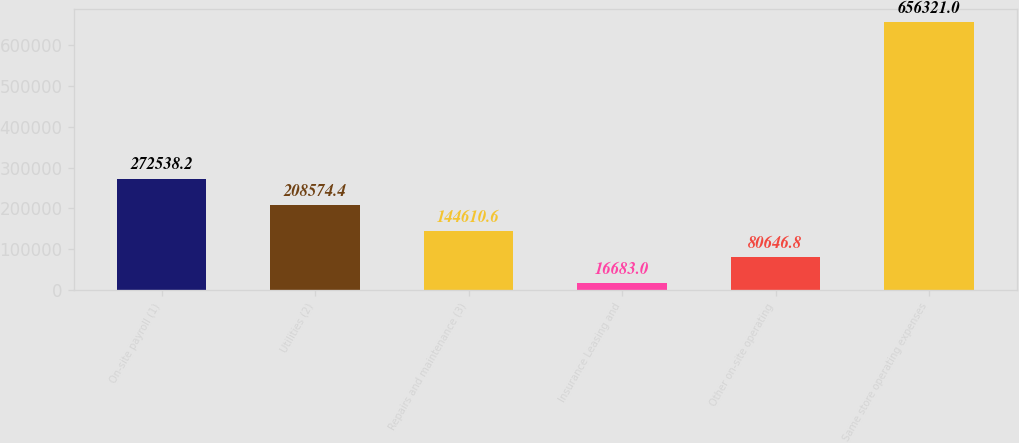Convert chart. <chart><loc_0><loc_0><loc_500><loc_500><bar_chart><fcel>On-site payroll (1)<fcel>Utilities (2)<fcel>Repairs and maintenance (3)<fcel>Insurance Leasing and<fcel>Other on-site operating<fcel>Same store operating expenses<nl><fcel>272538<fcel>208574<fcel>144611<fcel>16683<fcel>80646.8<fcel>656321<nl></chart> 